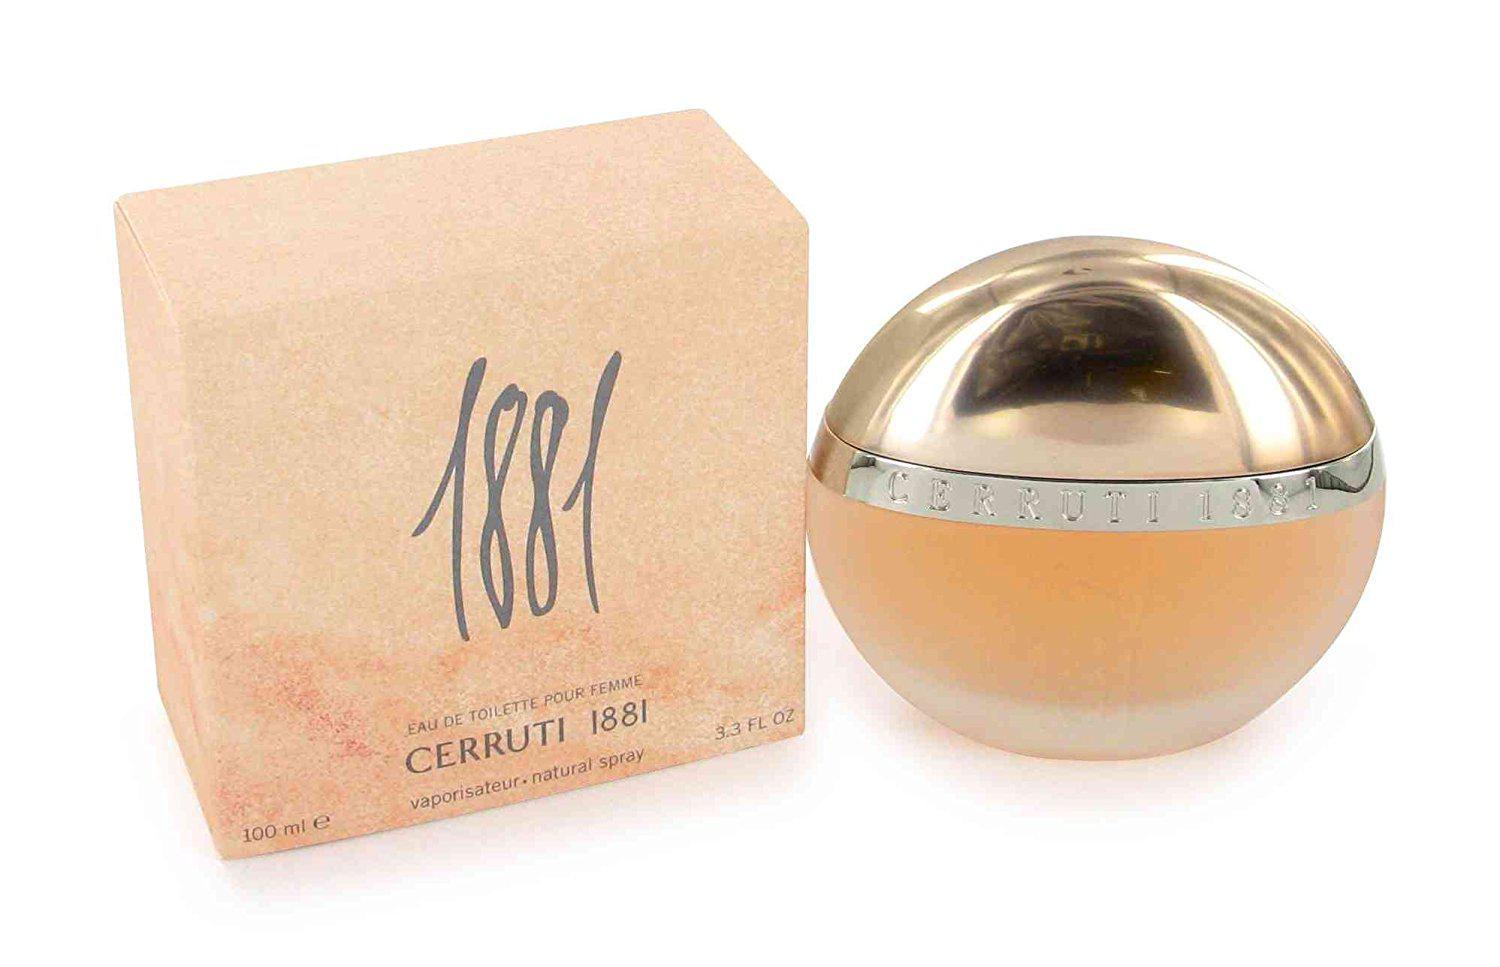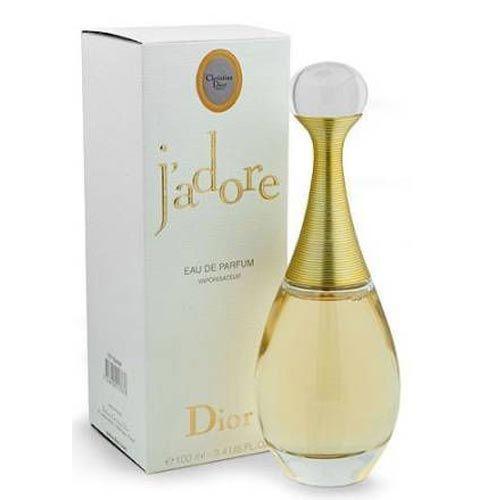The first image is the image on the left, the second image is the image on the right. For the images shown, is this caption "Each image contains at least three different fragrance bottles." true? Answer yes or no. No. The first image is the image on the left, the second image is the image on the right. Considering the images on both sides, is "A single vial of perfume is standing in each of the images." valid? Answer yes or no. Yes. 